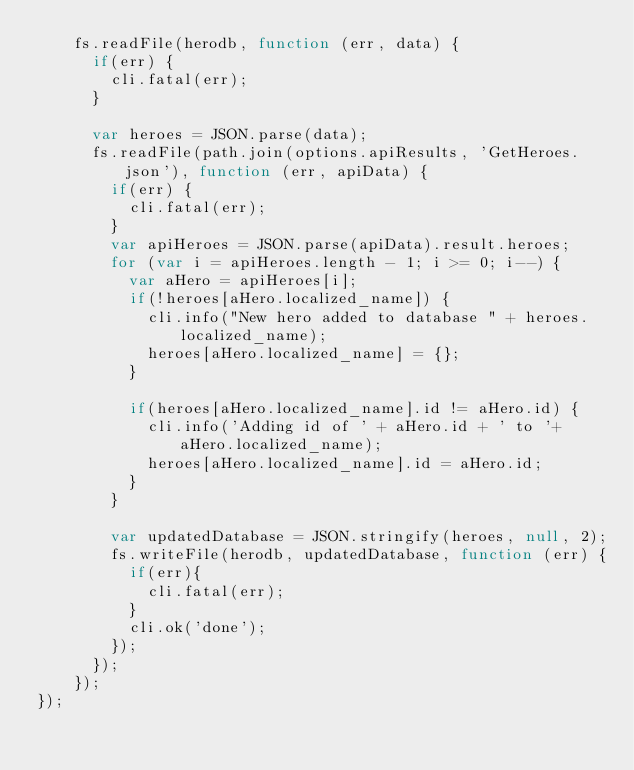<code> <loc_0><loc_0><loc_500><loc_500><_JavaScript_>    fs.readFile(herodb, function (err, data) {
      if(err) {
        cli.fatal(err);
      }

      var heroes = JSON.parse(data);
      fs.readFile(path.join(options.apiResults, 'GetHeroes.json'), function (err, apiData) {
        if(err) {
          cli.fatal(err);
        }
        var apiHeroes = JSON.parse(apiData).result.heroes;
        for (var i = apiHeroes.length - 1; i >= 0; i--) {
          var aHero = apiHeroes[i];
          if(!heroes[aHero.localized_name]) {
            cli.info("New hero added to database " + heroes.localized_name);
            heroes[aHero.localized_name] = {};
          }

          if(heroes[aHero.localized_name].id != aHero.id) {
            cli.info('Adding id of ' + aHero.id + ' to '+ aHero.localized_name);
            heroes[aHero.localized_name].id = aHero.id;
          }
        }

        var updatedDatabase = JSON.stringify(heroes, null, 2);
        fs.writeFile(herodb, updatedDatabase, function (err) {
          if(err){
            cli.fatal(err);
          }
          cli.ok('done');
        });
      });
    });
});</code> 